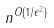<formula> <loc_0><loc_0><loc_500><loc_500>n ^ { O ( 1 / \epsilon ^ { 2 } ) }</formula> 